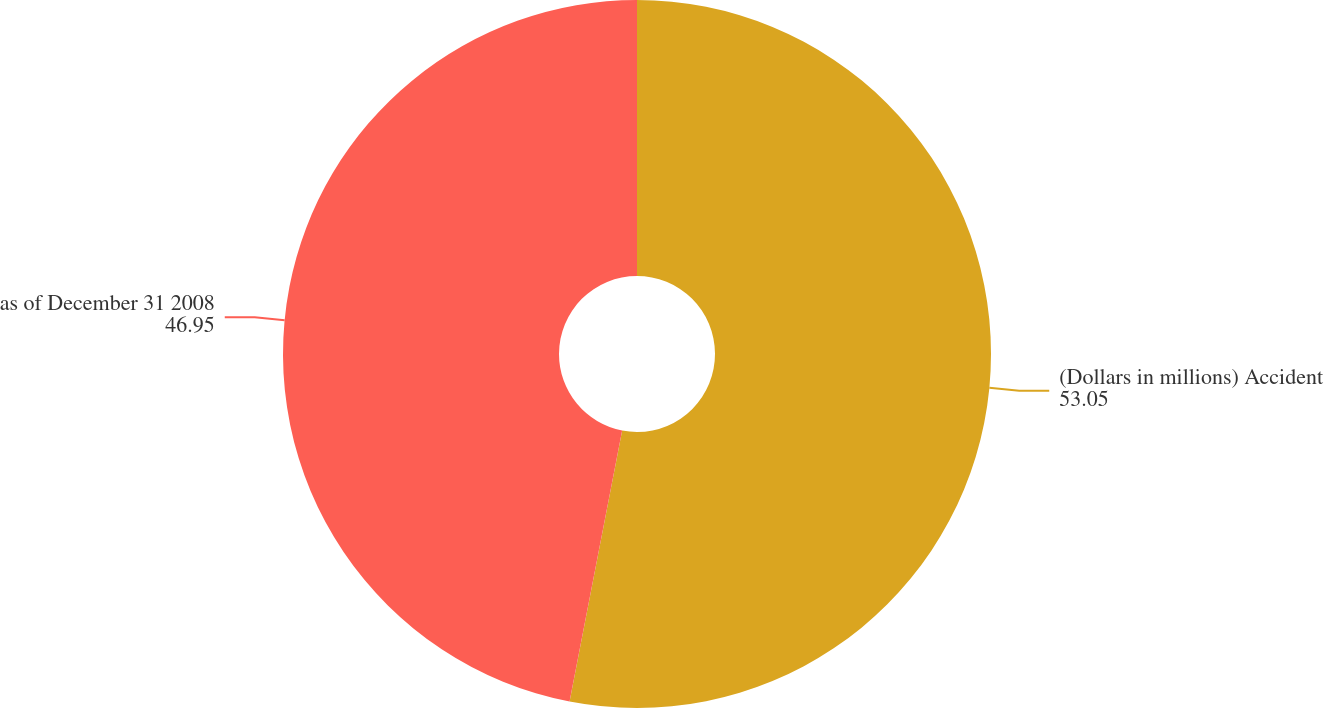Convert chart to OTSL. <chart><loc_0><loc_0><loc_500><loc_500><pie_chart><fcel>(Dollars in millions) Accident<fcel>as of December 31 2008<nl><fcel>53.05%<fcel>46.95%<nl></chart> 